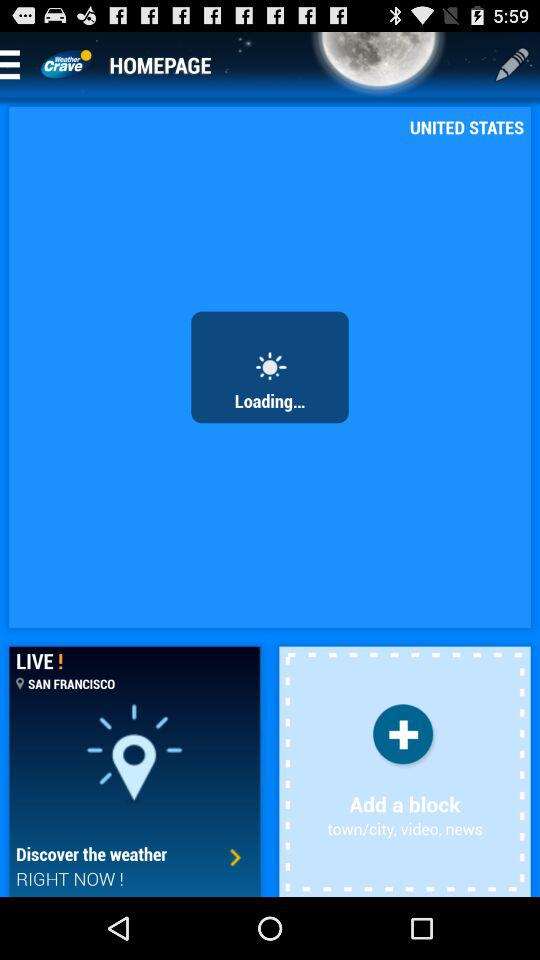Which country is mentioned? The mentioned country is the United States. 